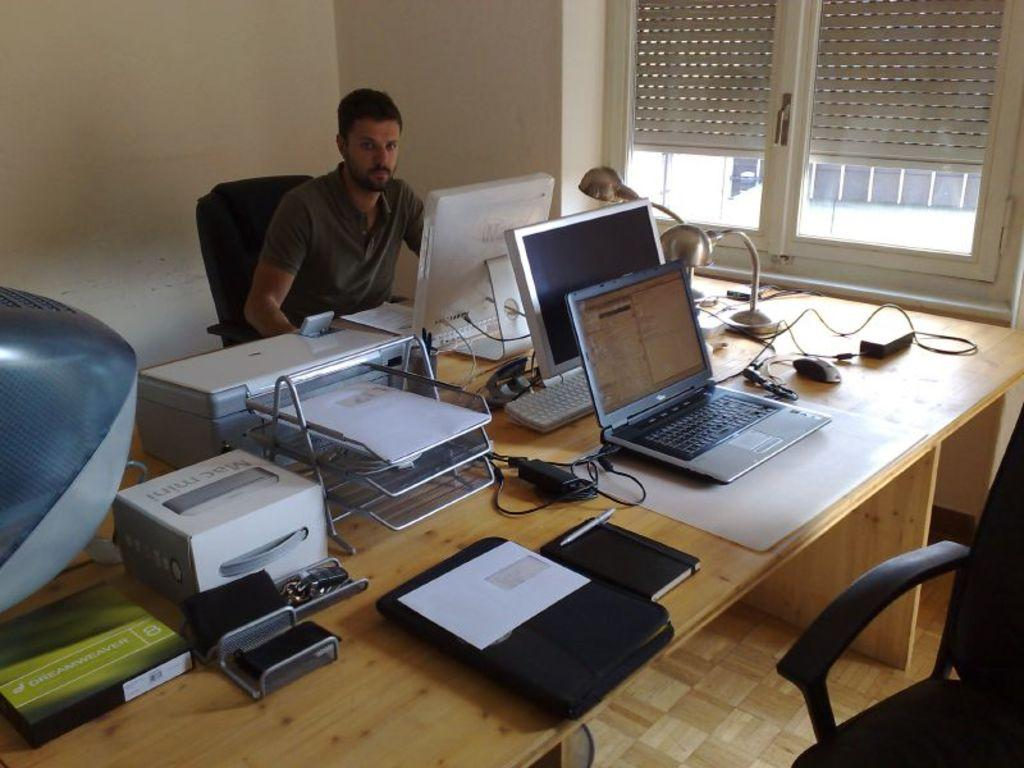What color is the wall in the image? The wall in the image is white. What can be seen on the wall in the image? There is a window on the wall in the image. What furniture is present in the image? There is a chair and a table in the image. What is on the table in the image? There is a laptop, papers, a mouse, and a mobile phone on the table in the image. What type of scent can be detected in the image? There is no mention of a scent in the image, so it cannot be determined from the image. --- Facts: 1. There is a person standing in the image. 2. The person is wearing a hat. 3. The person is holding a book. 4. There is a tree in the background of the image. 5. The sky is visible in the image. Absurd Topics: parrot, sand, ocean Conversation: What is the person in the image doing? The person in the image is standing. What is the person wearing in the image? The person is wearing a hat in the image. What is the person holding in the image? The person is holding a book in the image. What can be seen in the background of the image? There is a tree in the background of the image. What is visible at the top of the image? The sky is visible in the image. Reasoning: Let's think step by step in order to produce the conversation. We start by identifying the main subject in the image, which is the person standing. Then, we expand the conversation to include other details about the person, such as their hat and the book they are holding. Finally, we focus on the background and sky, which provide context for the image. Each question is designed to elicit a specific detail about the image that is known from the provided facts. Absurd Question/Answer: Can you see any parrots in the image? There are no parrots present in the image. What type of sand can be seen on the ground in the image? There is no sand visible in the image; it appears to be a grassy or paved area. 